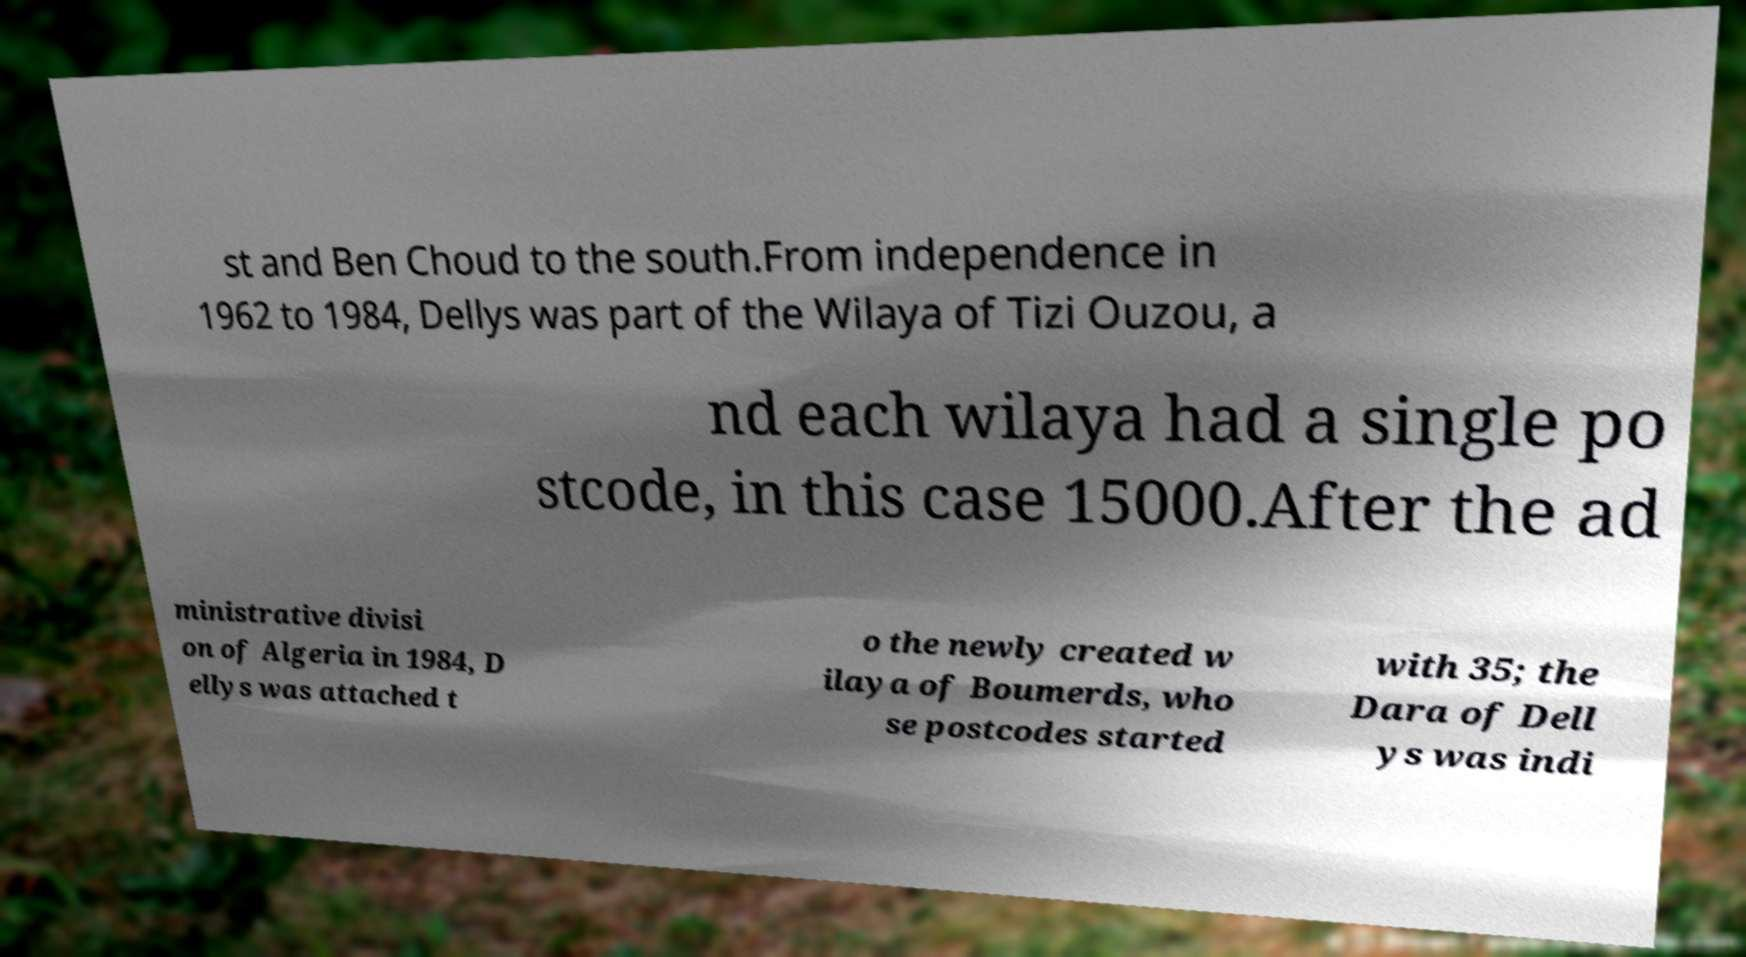For documentation purposes, I need the text within this image transcribed. Could you provide that? st and Ben Choud to the south.From independence in 1962 to 1984, Dellys was part of the Wilaya of Tizi Ouzou, a nd each wilaya had a single po stcode, in this case 15000.After the ad ministrative divisi on of Algeria in 1984, D ellys was attached t o the newly created w ilaya of Boumerds, who se postcodes started with 35; the Dara of Dell ys was indi 